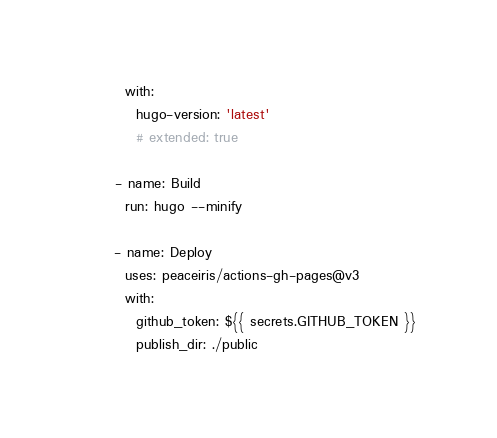Convert code to text. <code><loc_0><loc_0><loc_500><loc_500><_YAML_>        with:
          hugo-version: 'latest'
          # extended: true

      - name: Build
        run: hugo --minify

      - name: Deploy
        uses: peaceiris/actions-gh-pages@v3
        with:
          github_token: ${{ secrets.GITHUB_TOKEN }}
          publish_dir: ./public
</code> 